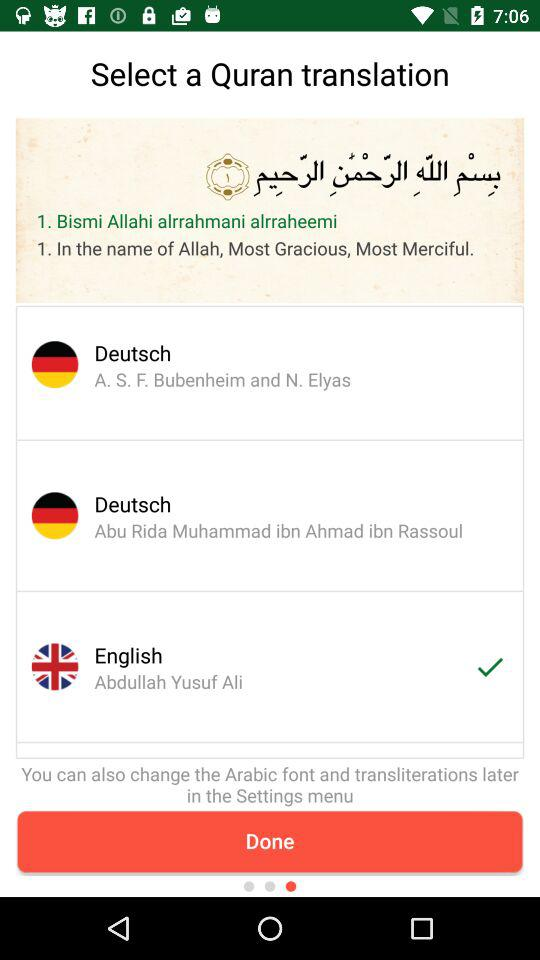Which option is selected? The selected option is "English". 